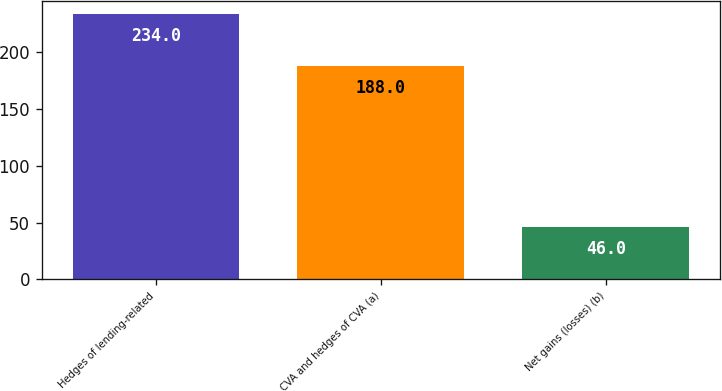Convert chart to OTSL. <chart><loc_0><loc_0><loc_500><loc_500><bar_chart><fcel>Hedges of lending-related<fcel>CVA and hedges of CVA (a)<fcel>Net gains (losses) (b)<nl><fcel>234<fcel>188<fcel>46<nl></chart> 